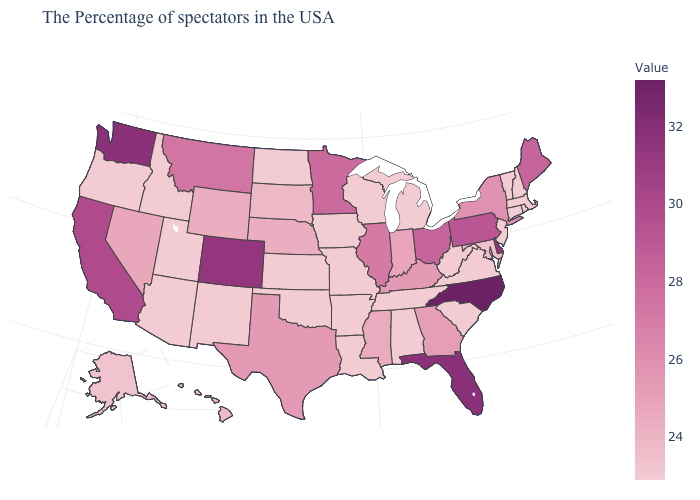Does Washington have a lower value than Minnesota?
Be succinct. No. Which states have the lowest value in the USA?
Be succinct. Massachusetts, Rhode Island, New Hampshire, Vermont, Connecticut, New Jersey, Virginia, South Carolina, West Virginia, Michigan, Alabama, Tennessee, Wisconsin, Louisiana, Missouri, Arkansas, Iowa, Kansas, Oklahoma, North Dakota, New Mexico, Utah, Arizona, Idaho, Oregon. Which states have the highest value in the USA?
Answer briefly. North Carolina. Which states hav the highest value in the West?
Answer briefly. Washington. Does Georgia have the highest value in the USA?
Give a very brief answer. No. Among the states that border Vermont , does Massachusetts have the highest value?
Be succinct. No. 